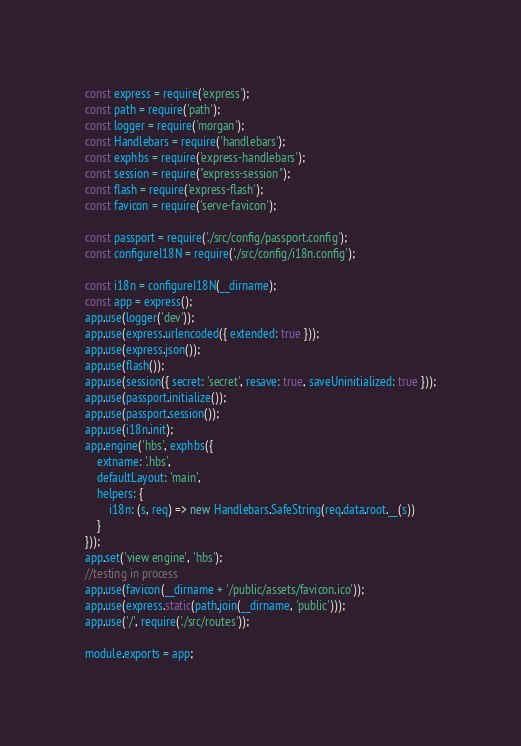Convert code to text. <code><loc_0><loc_0><loc_500><loc_500><_JavaScript_>const express = require('express');
const path = require('path');
const logger = require('morgan');
const Handlebars = require('handlebars');
const exphbs = require('express-handlebars');
const session = require("express-session");
const flash = require('express-flash');
const favicon = require('serve-favicon');

const passport = require('./src/config/passport.config');
const configureI18N = require('./src/config/i18n.config');

const i18n = configureI18N(__dirname);
const app = express();
app.use(logger('dev'));
app.use(express.urlencoded({ extended: true }));
app.use(express.json());
app.use(flash());
app.use(session({ secret: 'secret', resave: true, saveUninitialized: true }));
app.use(passport.initialize());
app.use(passport.session());
app.use(i18n.init);
app.engine('hbs', exphbs({
    extname: '.hbs',
    defaultLayout: 'main',
    helpers: {
        i18n: (s, req) => new Handlebars.SafeString(req.data.root.__(s))
    }
}));
app.set('view engine', 'hbs');
//testing in process
app.use(favicon(__dirname + '/public/assets/favicon.ico'));
app.use(express.static(path.join(__dirname, 'public')));
app.use('/', require('./src/routes'));

module.exports = app;</code> 